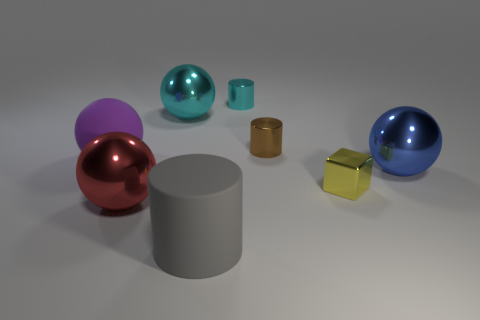What is the color of the large metal sphere that is in front of the large shiny sphere to the right of the gray object?
Your answer should be very brief. Red. There is a cylinder that is to the right of the cylinder behind the cyan shiny thing that is to the left of the small cyan shiny cylinder; how big is it?
Give a very brief answer. Small. What is the shape of the big gray thing?
Offer a very short reply. Cylinder. What number of large cylinders are behind the metal block in front of the big cyan metallic sphere?
Keep it short and to the point. 0. How many other objects are the same material as the purple ball?
Provide a succinct answer. 1. Is the material of the sphere that is to the right of the yellow shiny thing the same as the tiny cylinder on the right side of the tiny cyan shiny cylinder?
Give a very brief answer. Yes. Is there anything else that is the same shape as the red thing?
Keep it short and to the point. Yes. Does the tiny block have the same material as the ball that is behind the big purple object?
Make the answer very short. Yes. There is a sphere that is behind the shiny cylinder in front of the metal sphere behind the big purple thing; what is its color?
Make the answer very short. Cyan. There is a brown metal object that is the same size as the yellow thing; what shape is it?
Make the answer very short. Cylinder. 